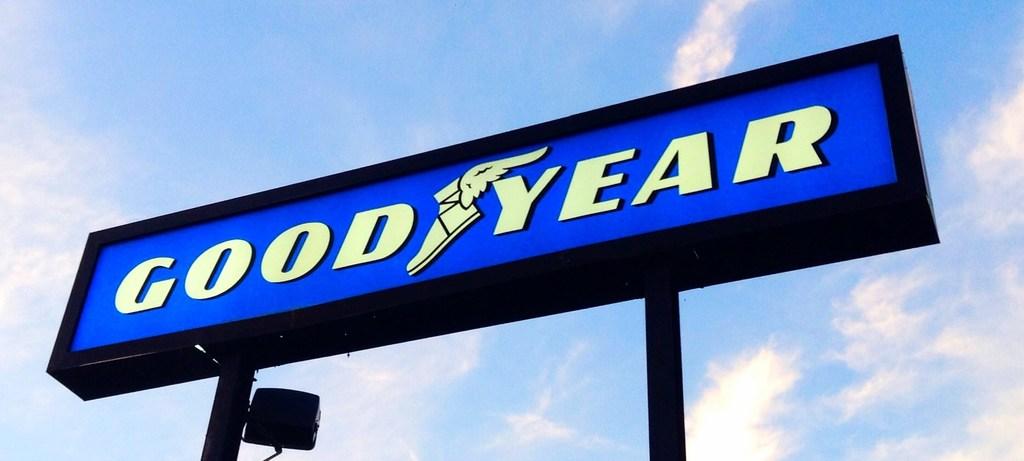What tire company brand name sign is displayed?
Offer a terse response. Goodyear. 